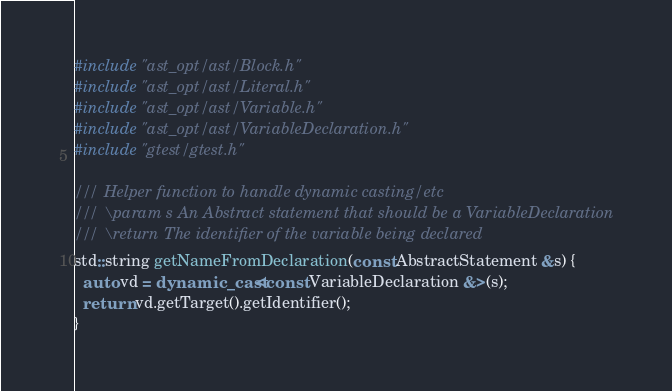<code> <loc_0><loc_0><loc_500><loc_500><_C++_>#include "ast_opt/ast/Block.h"
#include "ast_opt/ast/Literal.h"
#include "ast_opt/ast/Variable.h"
#include "ast_opt/ast/VariableDeclaration.h"
#include "gtest/gtest.h"

/// Helper function to handle dynamic casting/etc
/// \param s An Abstract statement that should be a VariableDeclaration
/// \return The identifier of the variable being declared
std::string getNameFromDeclaration(const AbstractStatement &s) {
  auto vd = dynamic_cast<const VariableDeclaration &>(s);
  return vd.getTarget().getIdentifier();
}
</code> 